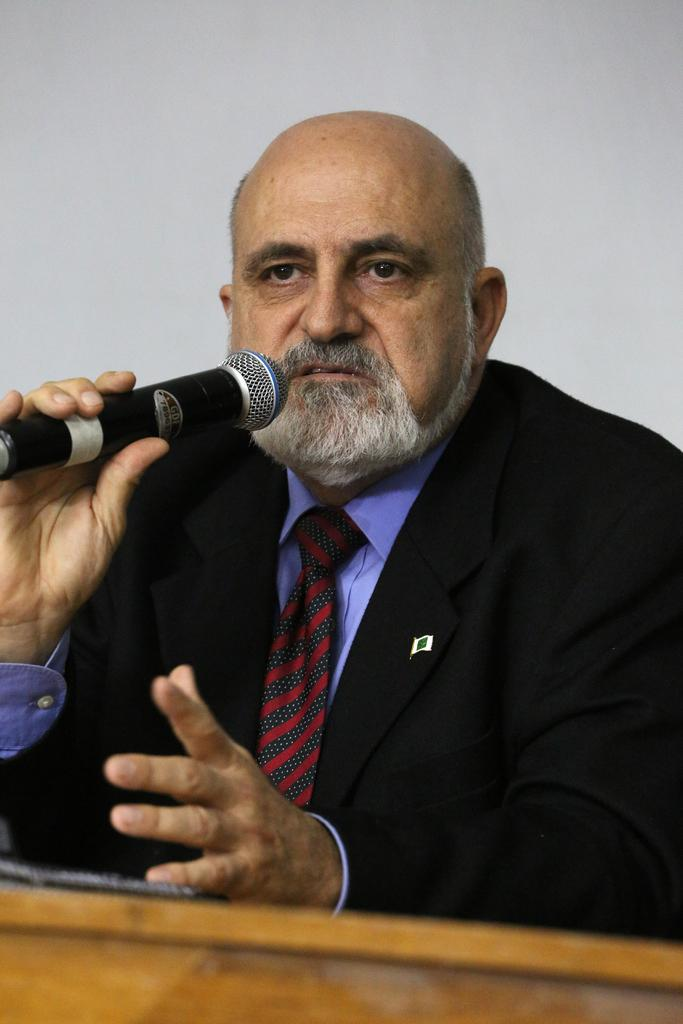Who is present in the image? There is a man in the picture. What is the man wearing? The man is wearing a blue shirt and a black suit. What is the man holding in his hand? The man is holding a mic in his hand. What other object can be seen in the image? There is a wooden plank in the image. What type of liquid is being poured from the yoke in the image? There is no yoke or liquid present in the image. What type of field can be seen in the background of the image? There is no field visible in the image; it only shows a man, a mic, and a wooden plank. 